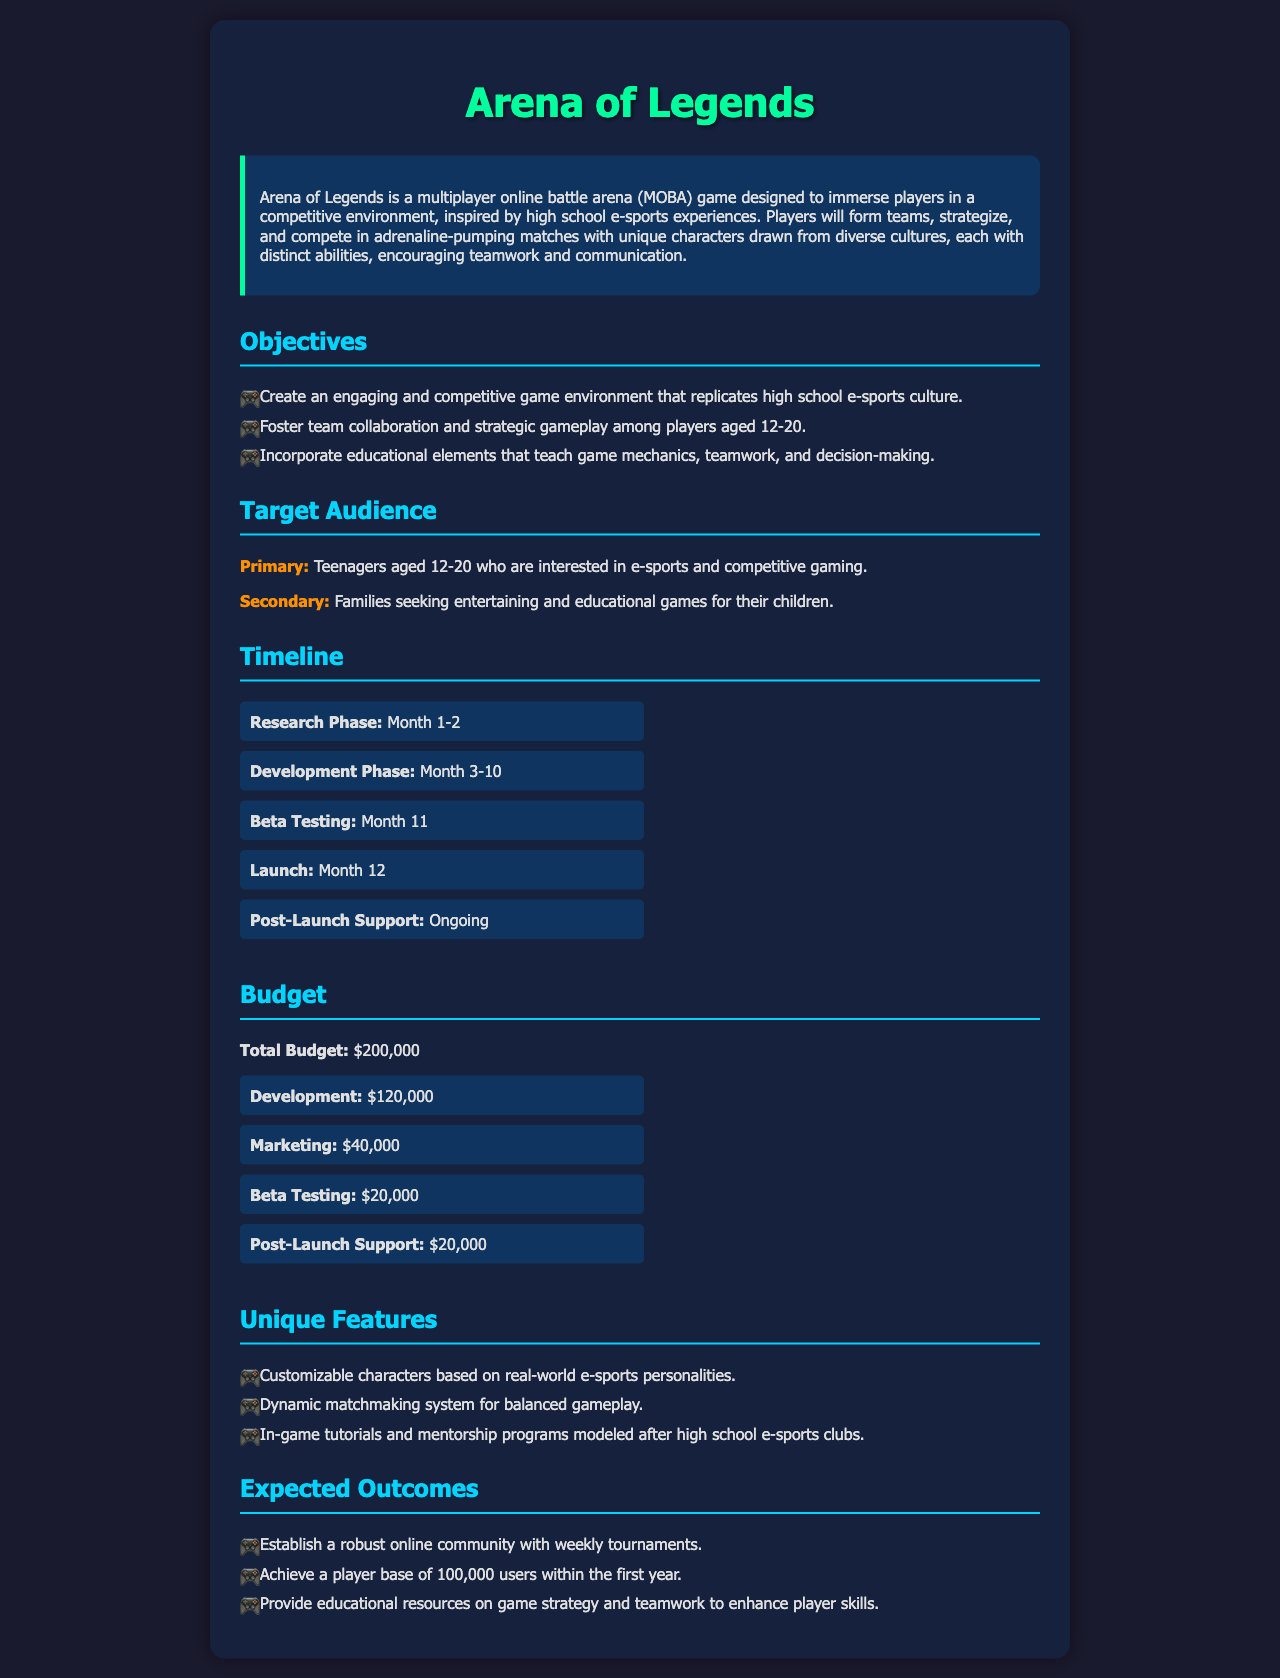What is the title of the game? The title of the game is stated directly in the document.
Answer: Arena of Legends What is the primary target audience age range? The primary target audience is described in a specific age range in the document.
Answer: 12-20 What is the budget allocated for development? The development budget is listed under the budget section of the document.
Answer: $120,000 How many months is the development phase scheduled to last? The duration of the development phase is mentioned in the timeline section.
Answer: 8 months What unique feature involves mentorship? The document notes a specific feature that includes mentorship programs.
Answer: In-game tutorials and mentorship programs What is the total budget for the project? The total budget is explicitly provided in the budget section of the document.
Answer: $200,000 What is one objective of the game? An objective of the game is mentioned in a bulleted list in the document.
Answer: Foster team collaboration and strategic gameplay What is the expected player base within the first year? The expected player base is specified in the expected outcomes section.
Answer: 100,000 users What phase follows the Beta Testing phase? The timeline section indicates what comes after beta testing.
Answer: Launch 